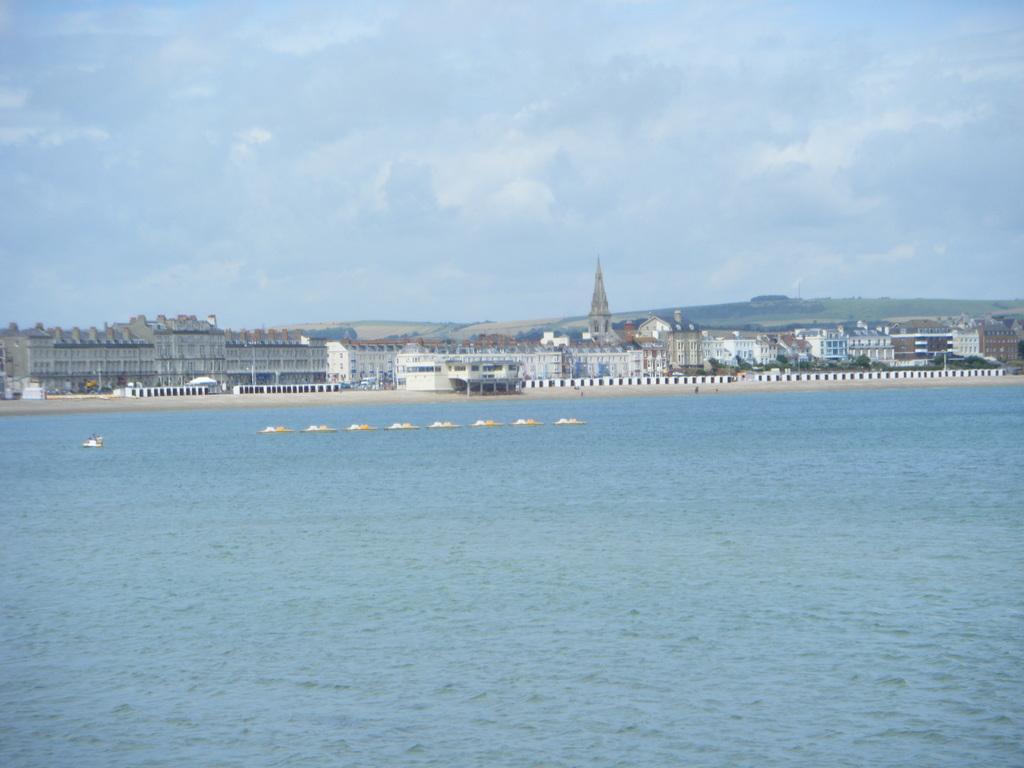How would you summarize this image in a sentence or two? In this picture I can see the water in front, on which there are few white and yellow color things and in the background I can see number of buildings and the cloudy sky. 